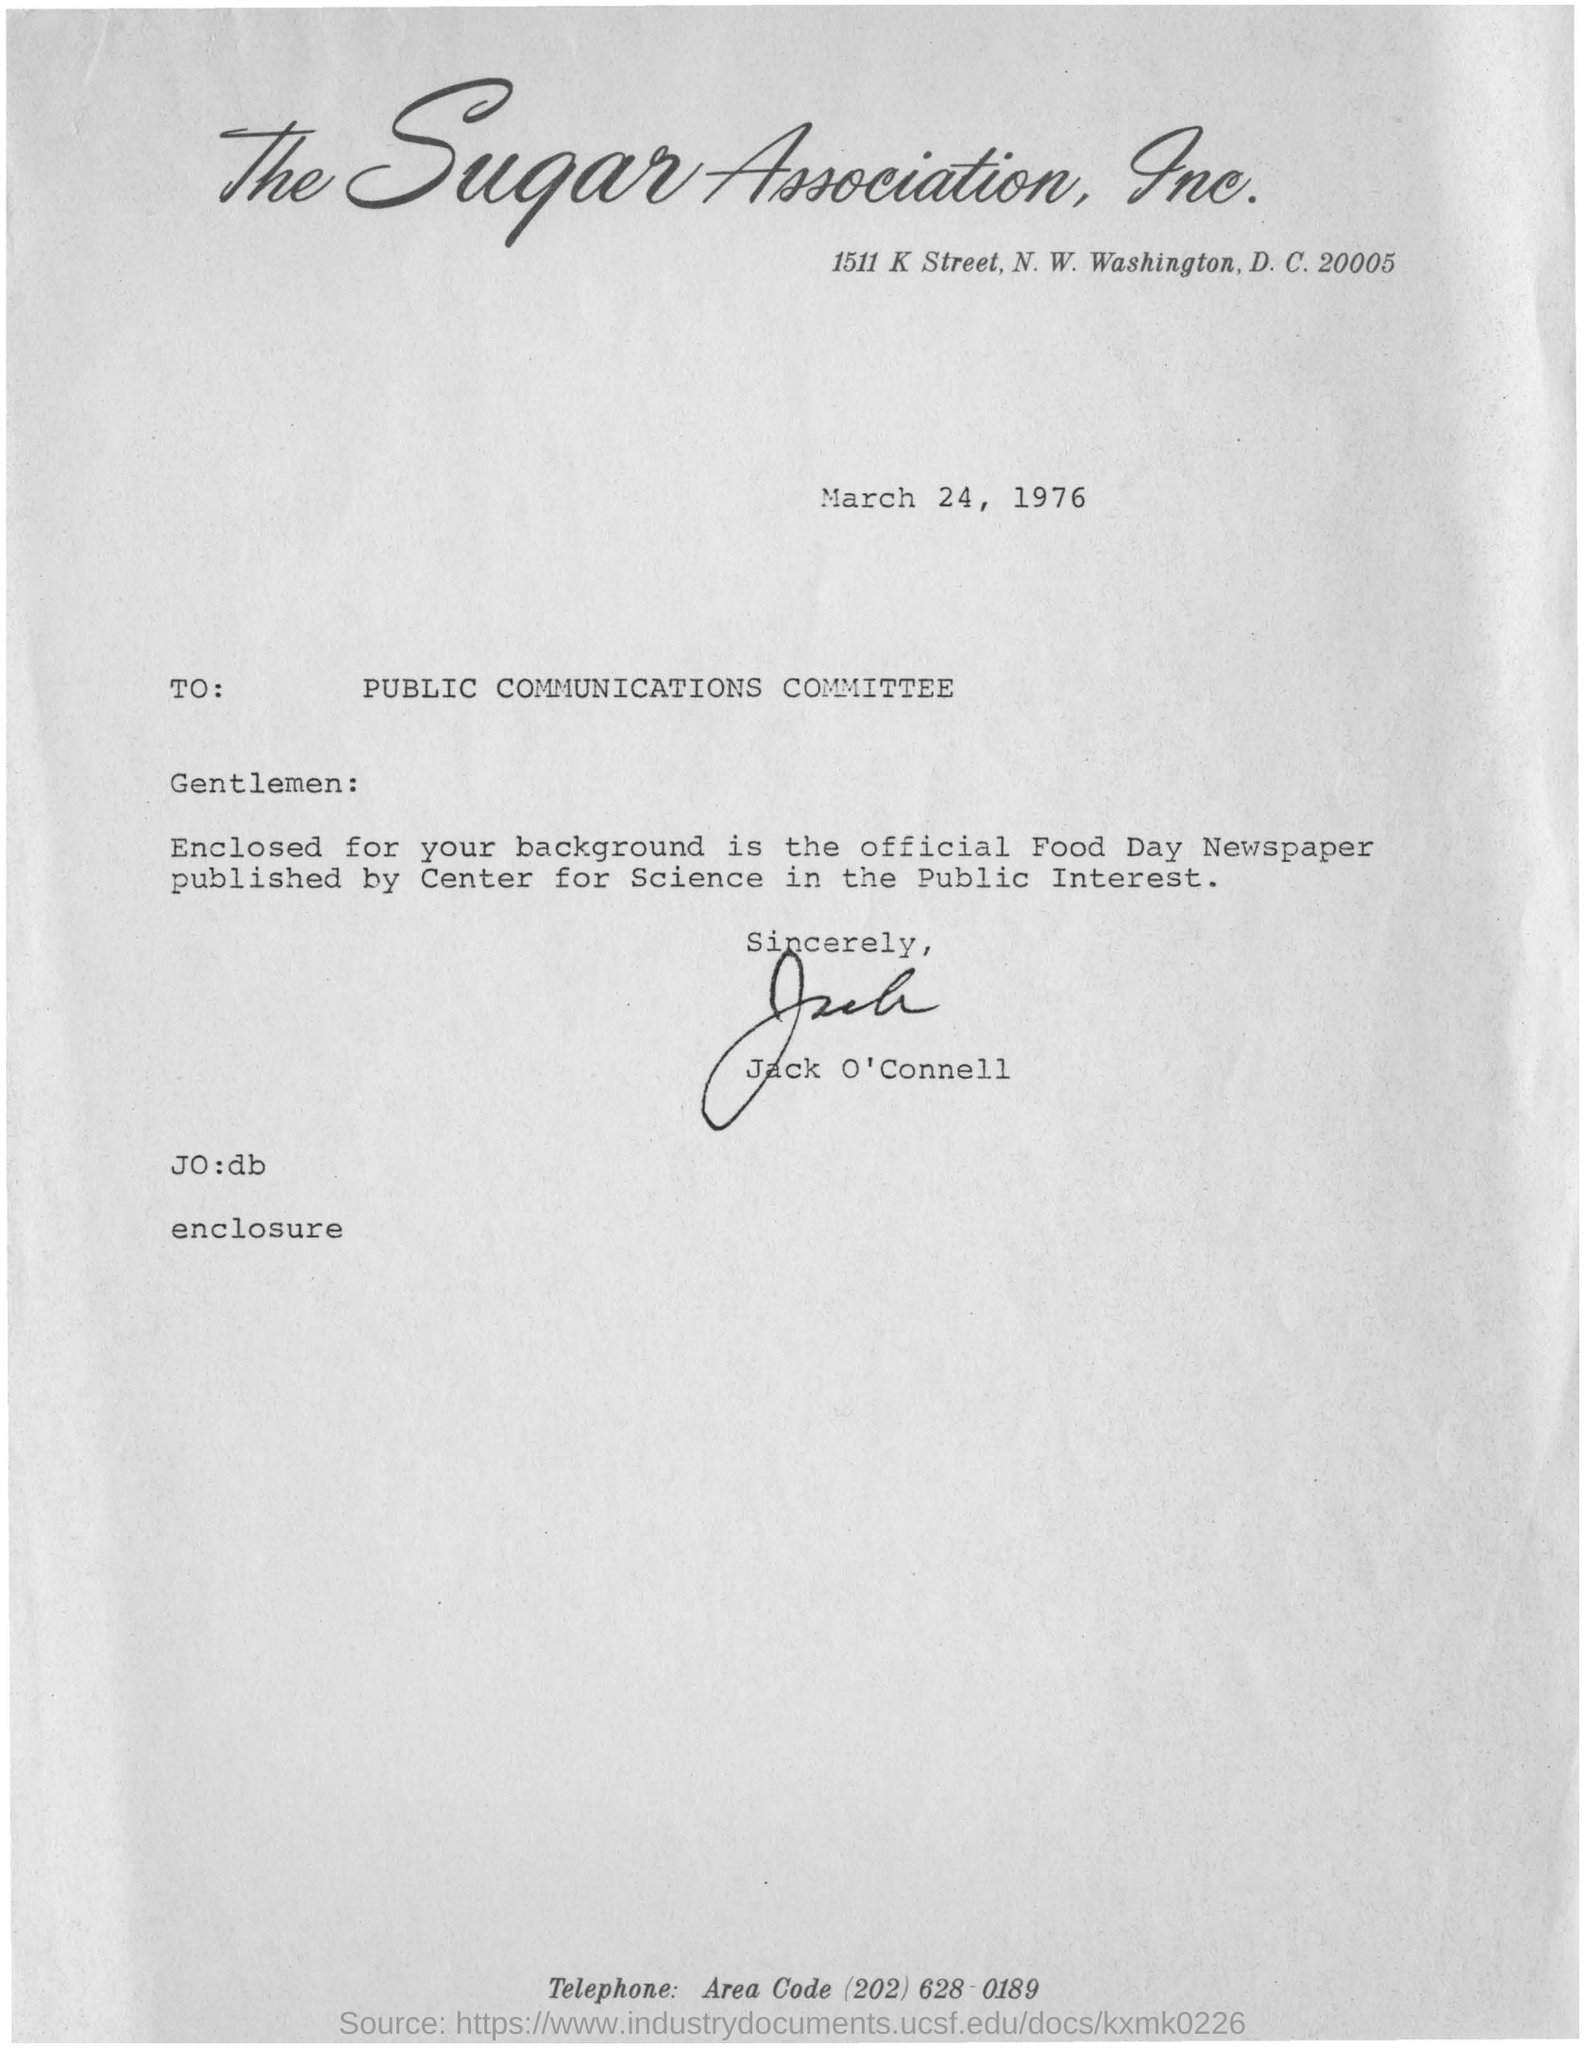What is the date on this letter?
Your answer should be very brief. March 24, 1976. Who is the letter addressed to?
Offer a very short reply. Public Communications Committee. Who has signed this letter?
Ensure brevity in your answer.  Jack O'Connell. Which company does the letterpad belong to?
Offer a very short reply. The Sugar Association, Inc. 